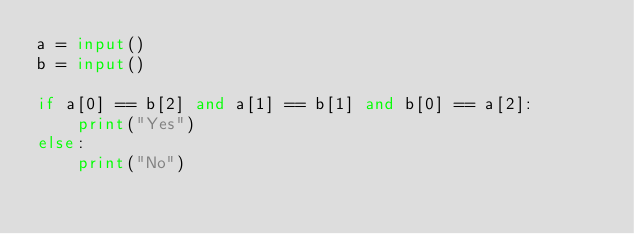Convert code to text. <code><loc_0><loc_0><loc_500><loc_500><_Python_>a = input()
b = input()

if a[0] == b[2] and a[1] == b[1] and b[0] == a[2]:
    print("Yes")
else:
    print("No")</code> 